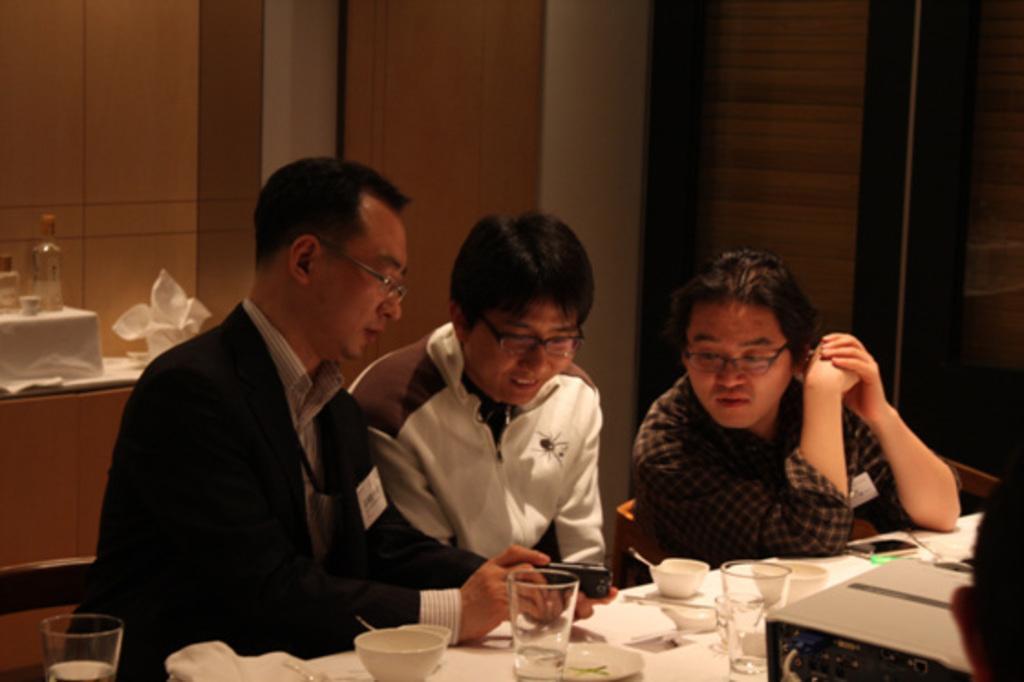Describe this image in one or two sentences. In the center of the image there are three people sitting on the chairs before them there is a table and there are glasses, cups, bowls napkins which are placed on the table. In the background there is a cup board and there are bottles placed on the cupboard. 